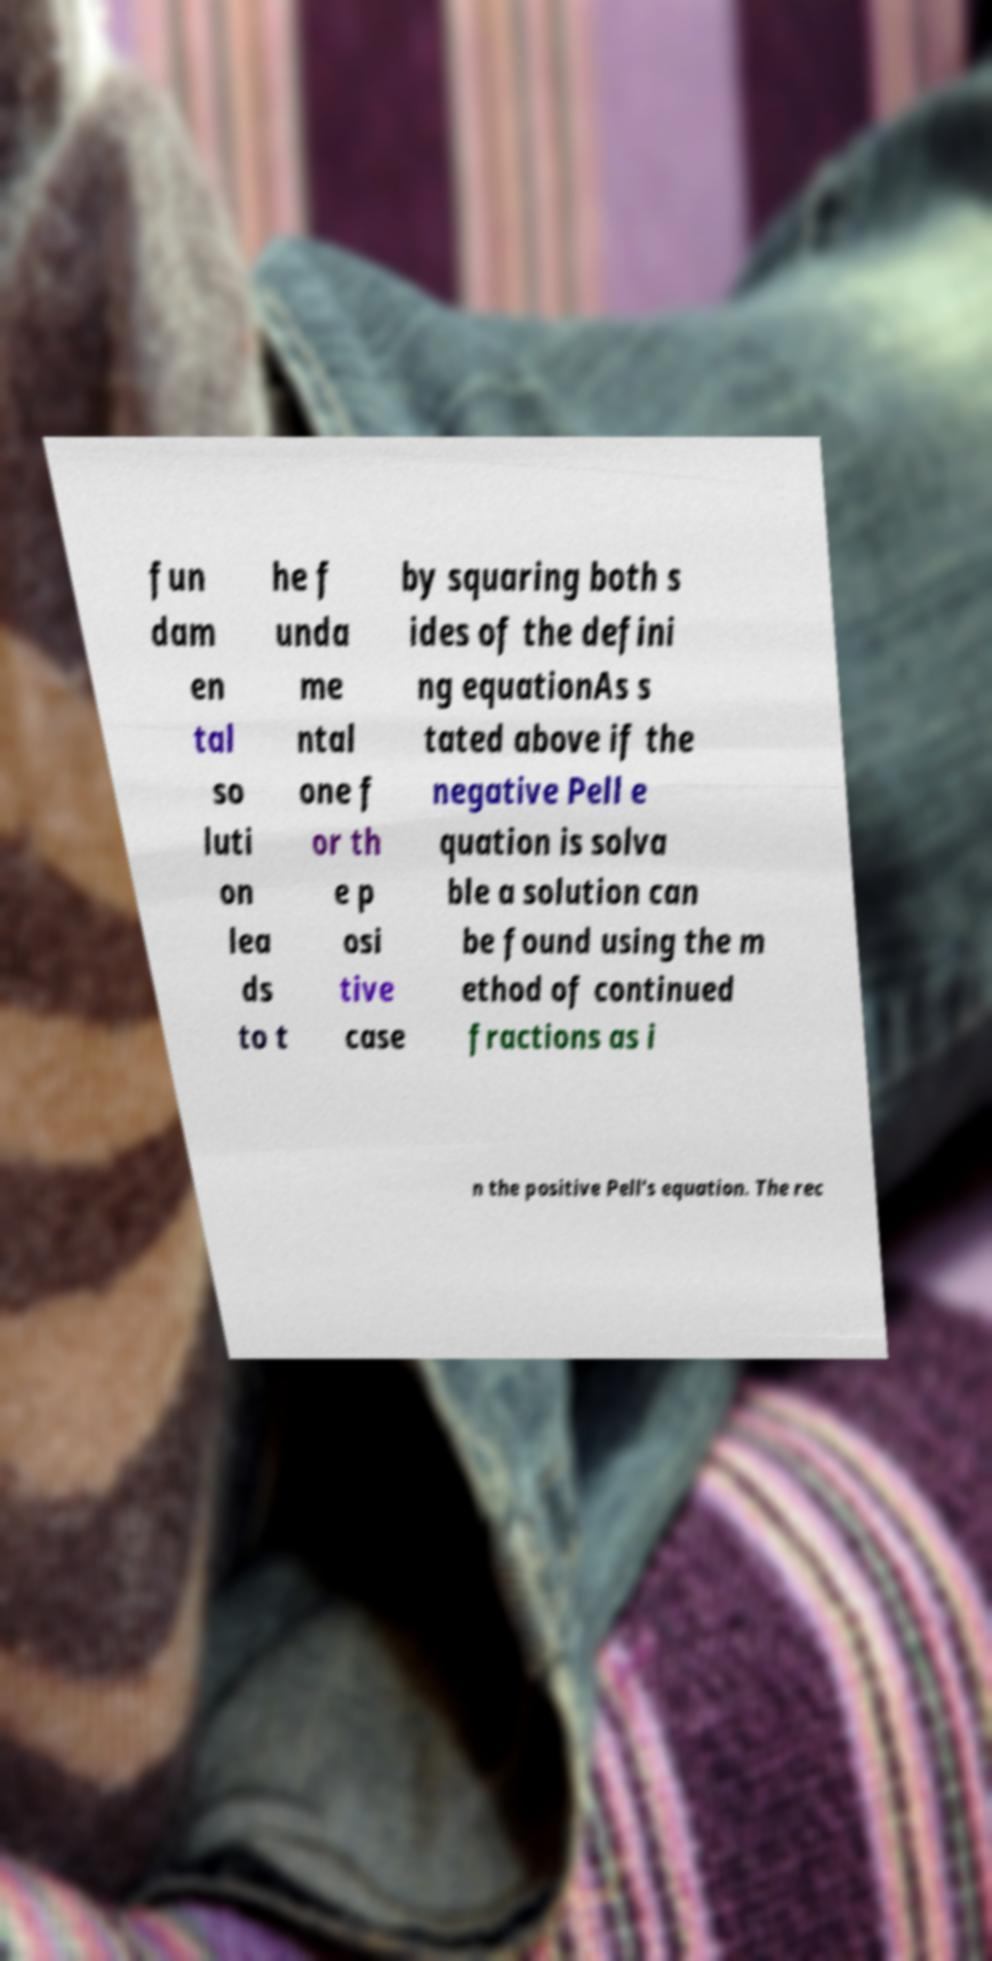Could you assist in decoding the text presented in this image and type it out clearly? fun dam en tal so luti on lea ds to t he f unda me ntal one f or th e p osi tive case by squaring both s ides of the defini ng equationAs s tated above if the negative Pell e quation is solva ble a solution can be found using the m ethod of continued fractions as i n the positive Pell's equation. The rec 